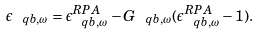<formula> <loc_0><loc_0><loc_500><loc_500>\epsilon _ { \ q b , \omega } = \epsilon _ { \ q b , \omega } ^ { R P A } - G _ { \ q b , \omega } ( \epsilon _ { \ q b , \omega } ^ { R P A } - 1 ) .</formula> 